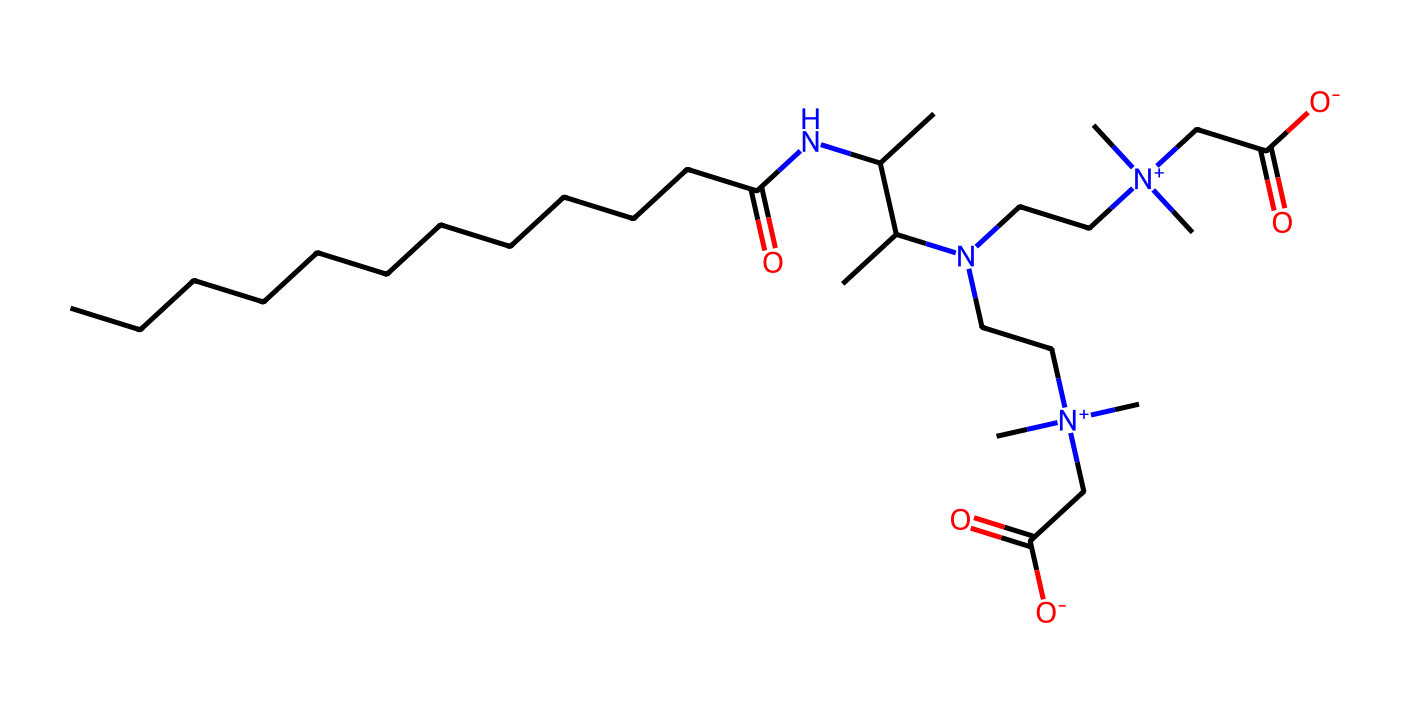What is the primary functional group present in this molecule? The molecule contains a carboxylate group (-COO-) due to the presence of the carbonyl (C=O) and hydroxyl (OH) parts, which qualifies it as a carboxylic acid derivative.
Answer: carboxylate How many nitrogen atoms are present in the structure? By examining the SMILES representation, we can identify four nitrogen atoms represented by 'N', which are attached to various carbons in the structure.
Answer: four What type of surfactant is cocamidopropyl betaine classified as? Cocamidopropyl betaine has both a polar (ammonium ion) and non-polar (hydrophobic alkyl chain) part, making it amphoteric, as it can function as either a cationic or anionic surfactant depending on the pH.
Answer: amphoteric What is the length of the hydrocarbon chain in the molecule? The hydrocarbon chain has 12 carbon atoms, as can be deduced from the initial section of the SMILES that indicates a linear carbon chain (CCCCCCCCCCCC).
Answer: twelve How many carbon atoms are found in the entire structure? Counting all the carbon atoms in the SMILES representation, including those in the hydrocarbon chain and the functional groups, totals 22 carbon atoms.
Answer: twenty-two What type of interaction would this surfactant most likely participate in with water? Due to its hydrophilic head (the betaine part) and hydrophobic tail (the long carbon chain), cocamidopropyl betaine is expected to engage in hydrogen bonding with water molecules.
Answer: hydrogen bonding 